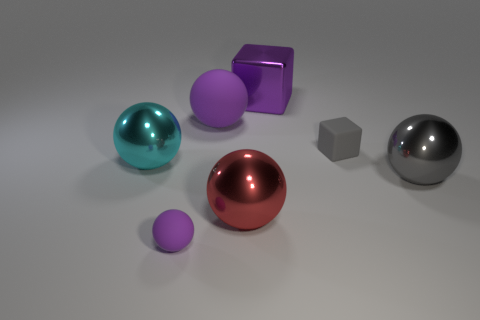Which objects in the image appear to be reflective? The spherical objects, especially the big gray metal ball and the red ball, exhibit strong reflective properties. The cube and the uniquely shaped purple object also have a reflective surface though not as pronounced as the spheres. 